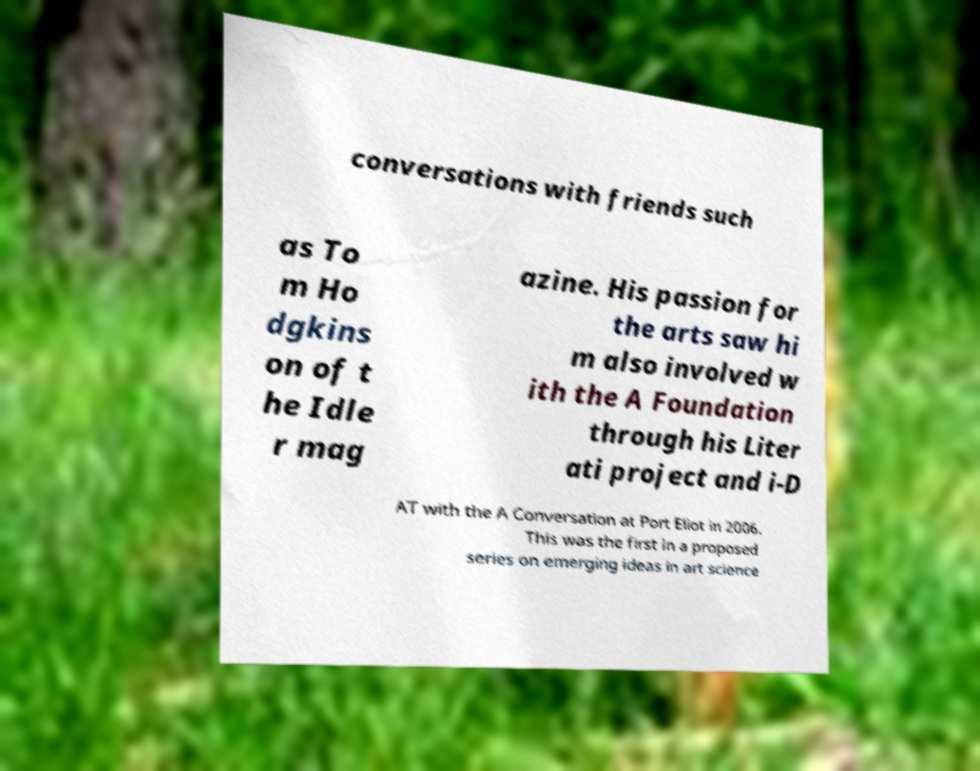I need the written content from this picture converted into text. Can you do that? conversations with friends such as To m Ho dgkins on of t he Idle r mag azine. His passion for the arts saw hi m also involved w ith the A Foundation through his Liter ati project and i-D AT with the A Conversation at Port Eliot in 2006. This was the first in a proposed series on emerging ideas in art science 